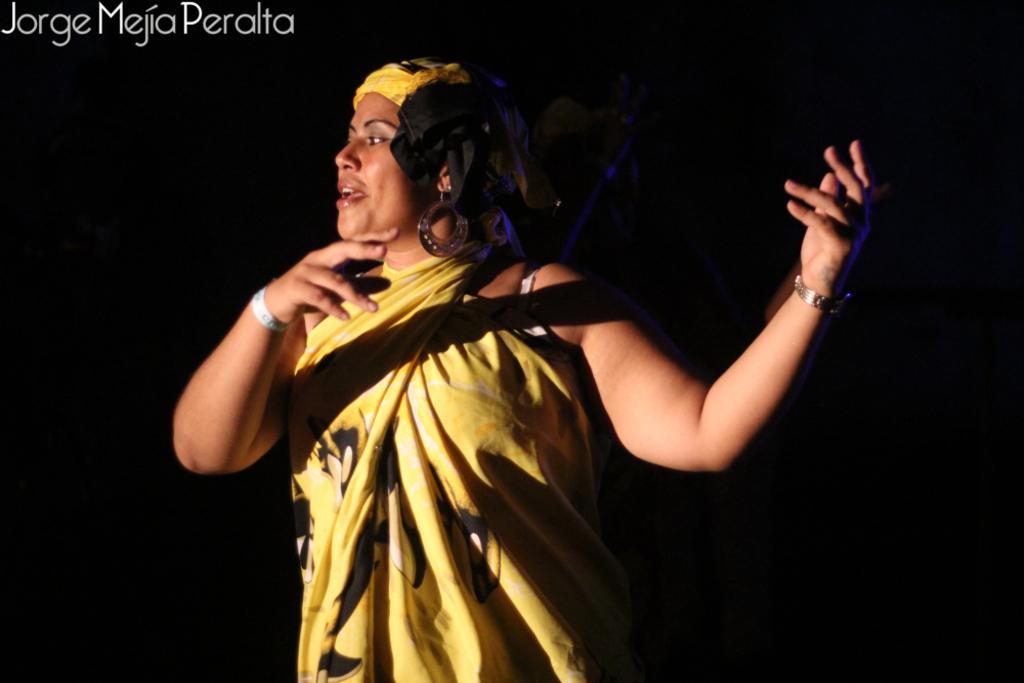Can you describe this image briefly? In this image we can see a woman. 